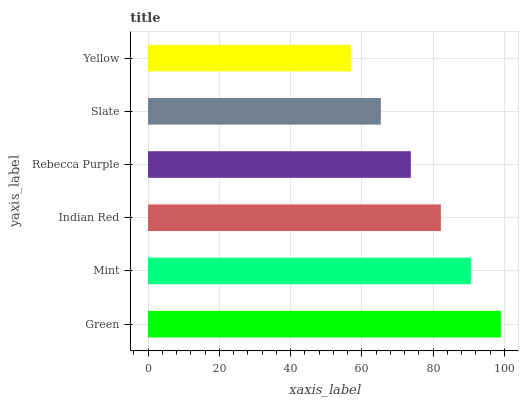Is Yellow the minimum?
Answer yes or no. Yes. Is Green the maximum?
Answer yes or no. Yes. Is Mint the minimum?
Answer yes or no. No. Is Mint the maximum?
Answer yes or no. No. Is Green greater than Mint?
Answer yes or no. Yes. Is Mint less than Green?
Answer yes or no. Yes. Is Mint greater than Green?
Answer yes or no. No. Is Green less than Mint?
Answer yes or no. No. Is Indian Red the high median?
Answer yes or no. Yes. Is Rebecca Purple the low median?
Answer yes or no. Yes. Is Mint the high median?
Answer yes or no. No. Is Yellow the low median?
Answer yes or no. No. 